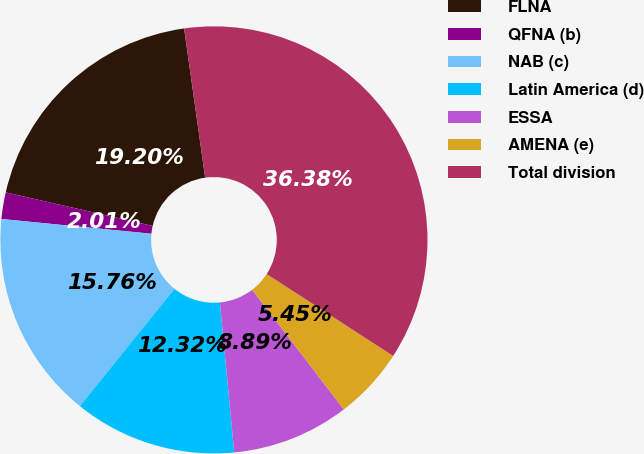Convert chart. <chart><loc_0><loc_0><loc_500><loc_500><pie_chart><fcel>FLNA<fcel>QFNA (b)<fcel>NAB (c)<fcel>Latin America (d)<fcel>ESSA<fcel>AMENA (e)<fcel>Total division<nl><fcel>19.2%<fcel>2.01%<fcel>15.76%<fcel>12.32%<fcel>8.89%<fcel>5.45%<fcel>36.38%<nl></chart> 